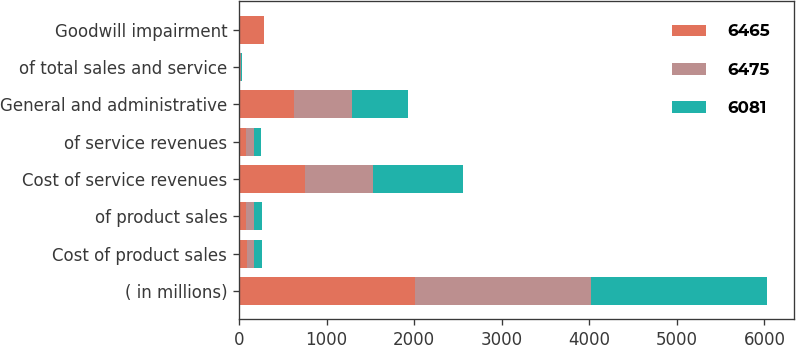<chart> <loc_0><loc_0><loc_500><loc_500><stacked_bar_chart><ecel><fcel>( in millions)<fcel>Cost of product sales<fcel>of product sales<fcel>Cost of service revenues<fcel>of service revenues<fcel>General and administrative<fcel>of total sales and service<fcel>Goodwill impairment<nl><fcel>6465<fcel>2011<fcel>87.5<fcel>84.5<fcel>757<fcel>84.2<fcel>624<fcel>9.5<fcel>290<nl><fcel>6475<fcel>2010<fcel>87.5<fcel>87<fcel>770<fcel>83.2<fcel>663<fcel>9.9<fcel>0<nl><fcel>6081<fcel>2009<fcel>87.5<fcel>87.5<fcel>1027<fcel>82.4<fcel>639<fcel>10.2<fcel>0<nl></chart> 